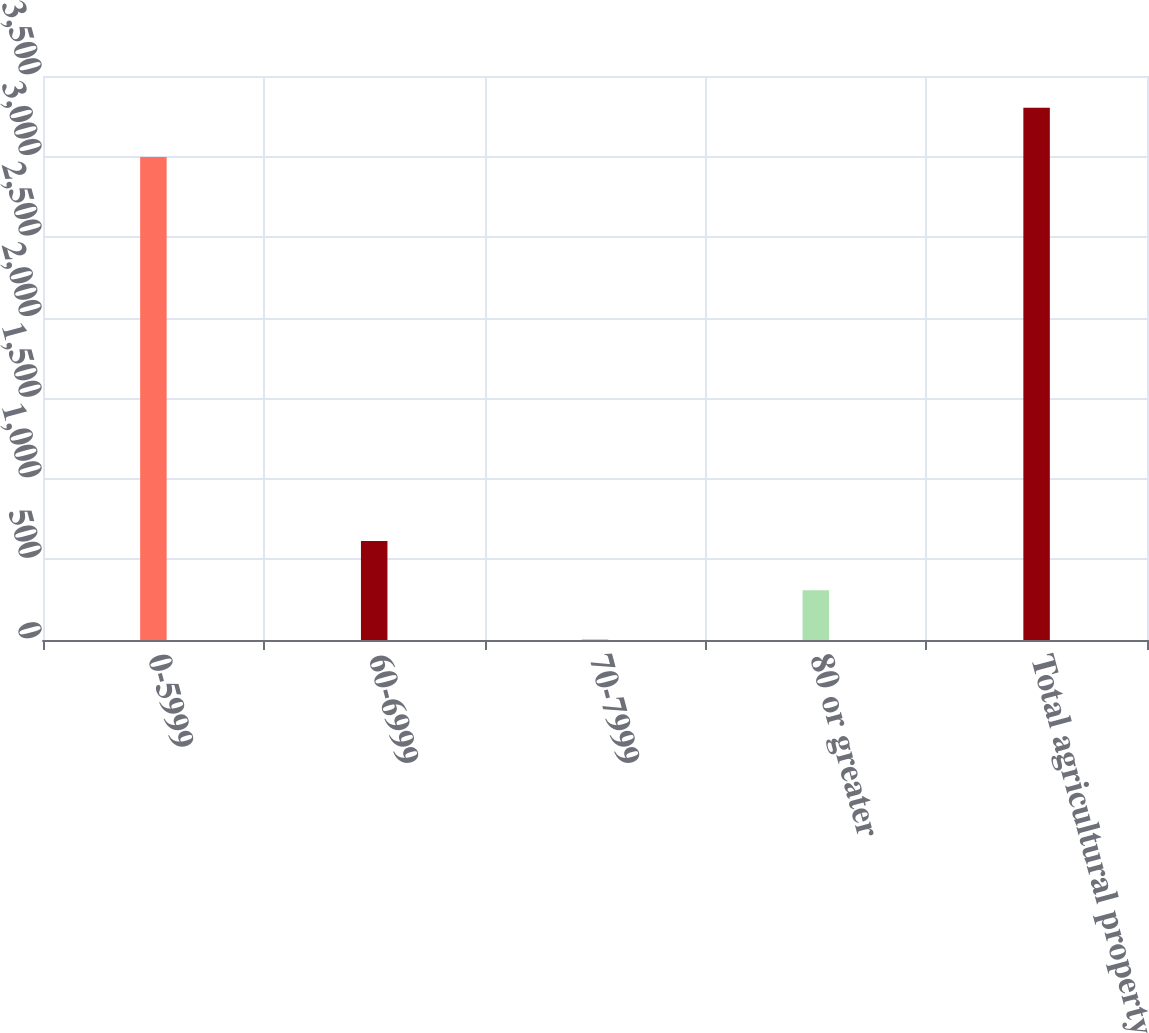<chart> <loc_0><loc_0><loc_500><loc_500><bar_chart><fcel>0-5999<fcel>60-6999<fcel>70-7999<fcel>80 or greater<fcel>Total agricultural property<nl><fcel>2997<fcel>614.01<fcel>2.27<fcel>308.14<fcel>3302.87<nl></chart> 